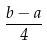<formula> <loc_0><loc_0><loc_500><loc_500>\frac { b - a } { 4 }</formula> 